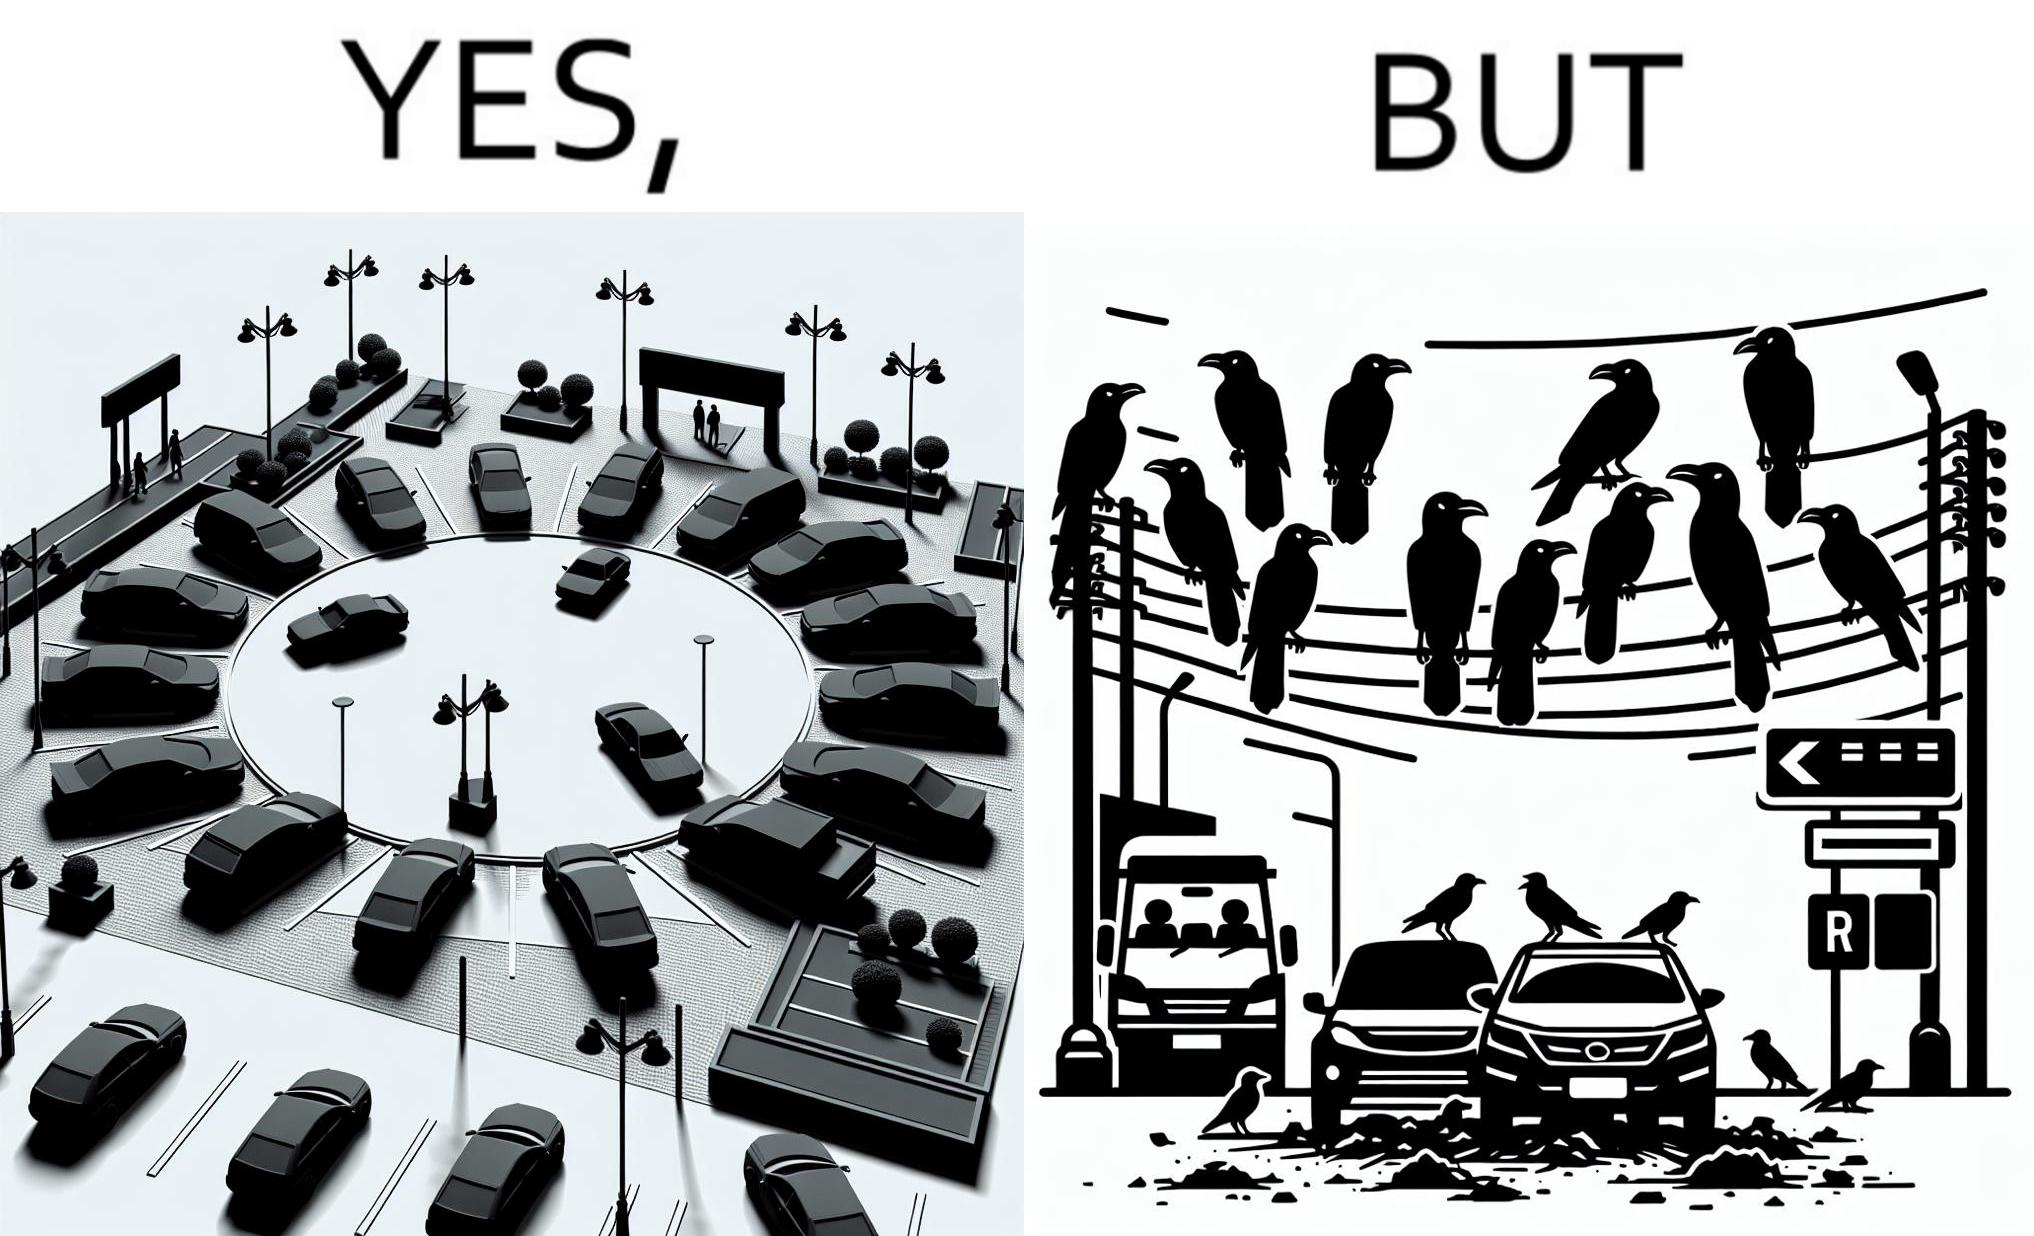What does this image depict? The image is ironical such that although there is a place for parking but that place is not suitable because if we place our car there then our car will become dirty from top due to crow beet. 